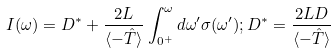Convert formula to latex. <formula><loc_0><loc_0><loc_500><loc_500>I ( \omega ) = D ^ { * } + \frac { 2 L } { \langle - \hat { T } \rangle } \int _ { 0 ^ { + } } ^ { \omega } d \omega ^ { \prime } \sigma ( \omega ^ { \prime } ) ; D ^ { * } = \frac { 2 L D } { \langle - \hat { T } \rangle }</formula> 